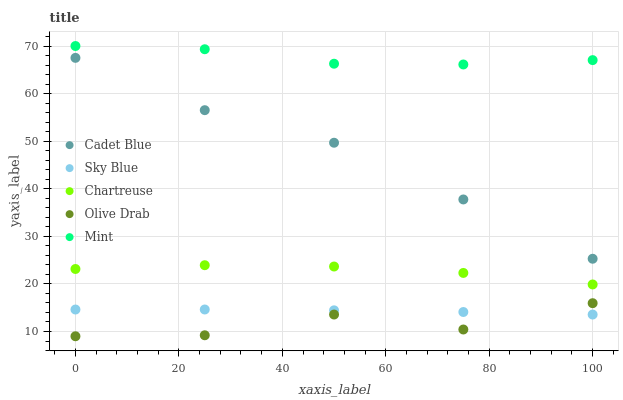Does Olive Drab have the minimum area under the curve?
Answer yes or no. Yes. Does Mint have the maximum area under the curve?
Answer yes or no. Yes. Does Chartreuse have the minimum area under the curve?
Answer yes or no. No. Does Chartreuse have the maximum area under the curve?
Answer yes or no. No. Is Sky Blue the smoothest?
Answer yes or no. Yes. Is Olive Drab the roughest?
Answer yes or no. Yes. Is Chartreuse the smoothest?
Answer yes or no. No. Is Chartreuse the roughest?
Answer yes or no. No. Does Olive Drab have the lowest value?
Answer yes or no. Yes. Does Chartreuse have the lowest value?
Answer yes or no. No. Does Mint have the highest value?
Answer yes or no. Yes. Does Chartreuse have the highest value?
Answer yes or no. No. Is Sky Blue less than Chartreuse?
Answer yes or no. Yes. Is Chartreuse greater than Sky Blue?
Answer yes or no. Yes. Does Olive Drab intersect Sky Blue?
Answer yes or no. Yes. Is Olive Drab less than Sky Blue?
Answer yes or no. No. Is Olive Drab greater than Sky Blue?
Answer yes or no. No. Does Sky Blue intersect Chartreuse?
Answer yes or no. No. 